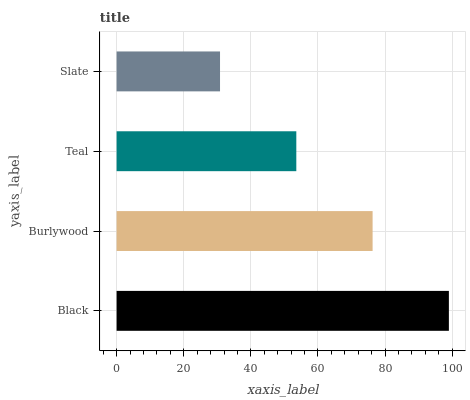Is Slate the minimum?
Answer yes or no. Yes. Is Black the maximum?
Answer yes or no. Yes. Is Burlywood the minimum?
Answer yes or no. No. Is Burlywood the maximum?
Answer yes or no. No. Is Black greater than Burlywood?
Answer yes or no. Yes. Is Burlywood less than Black?
Answer yes or no. Yes. Is Burlywood greater than Black?
Answer yes or no. No. Is Black less than Burlywood?
Answer yes or no. No. Is Burlywood the high median?
Answer yes or no. Yes. Is Teal the low median?
Answer yes or no. Yes. Is Teal the high median?
Answer yes or no. No. Is Black the low median?
Answer yes or no. No. 